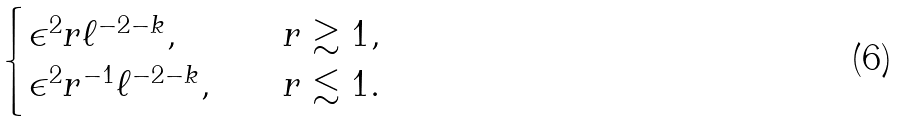Convert formula to latex. <formula><loc_0><loc_0><loc_500><loc_500>\begin{cases} \epsilon ^ { 2 } r \ell ^ { - 2 - k } , \quad & r \gtrsim 1 , \\ \epsilon ^ { 2 } r ^ { - 1 } \ell ^ { - 2 - k } , \quad & r \lesssim 1 . \end{cases}</formula> 